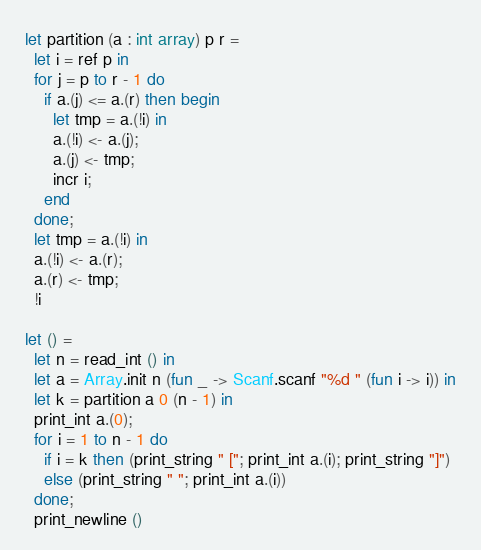Convert code to text. <code><loc_0><loc_0><loc_500><loc_500><_OCaml_>let partition (a : int array) p r =
  let i = ref p in
  for j = p to r - 1 do
    if a.(j) <= a.(r) then begin
      let tmp = a.(!i) in
      a.(!i) <- a.(j);
      a.(j) <- tmp;
      incr i;
    end
  done;
  let tmp = a.(!i) in
  a.(!i) <- a.(r);
  a.(r) <- tmp;
  !i

let () =
  let n = read_int () in
  let a = Array.init n (fun _ -> Scanf.scanf "%d " (fun i -> i)) in
  let k = partition a 0 (n - 1) in
  print_int a.(0);
  for i = 1 to n - 1 do
    if i = k then (print_string " ["; print_int a.(i); print_string "]")
    else (print_string " "; print_int a.(i))
  done;
  print_newline ()</code> 